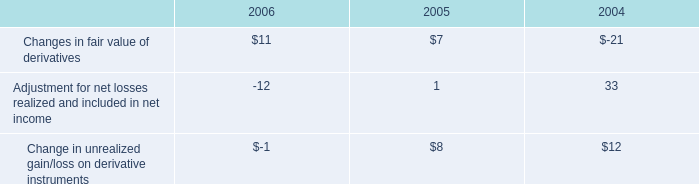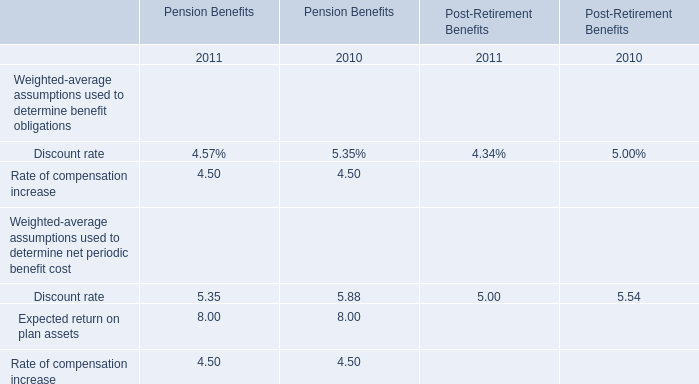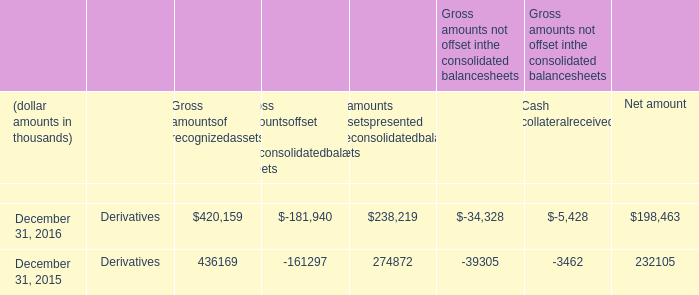What is the sum of the Rate of compensation increase for Pension Benefits in the years where Expected return on plan assets rate greater than 5 for Pension Benefits? 
Computations: (4.50 + 4.50)
Answer: 9.0. 